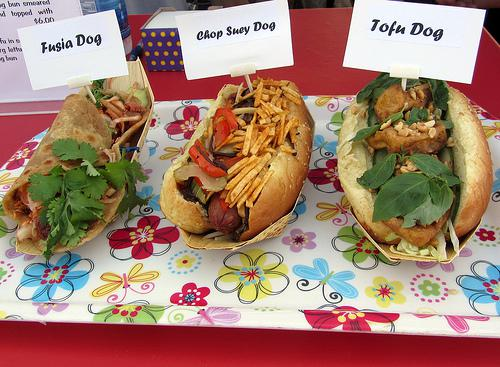Question: why are the foods displayed differently?
Choices:
A. Blind employee.
B. Lazy person.
C. Broken shelf.
D. According to the type.
Answer with the letter. Answer: D Question: how many types of food are on the table?
Choices:
A. Four types.
B. Three types.
C. One type.
D. Two types.
Answer with the letter. Answer: B Question: what is below the food bowls?
Choices:
A. Plate.
B. Wood table.
C. Picnic blanket.
D. A flowered tablecloth.
Answer with the letter. Answer: D Question: what is the color of the table?
Choices:
A. Blue.
B. Red.
C. Green.
D. White.
Answer with the letter. Answer: B 